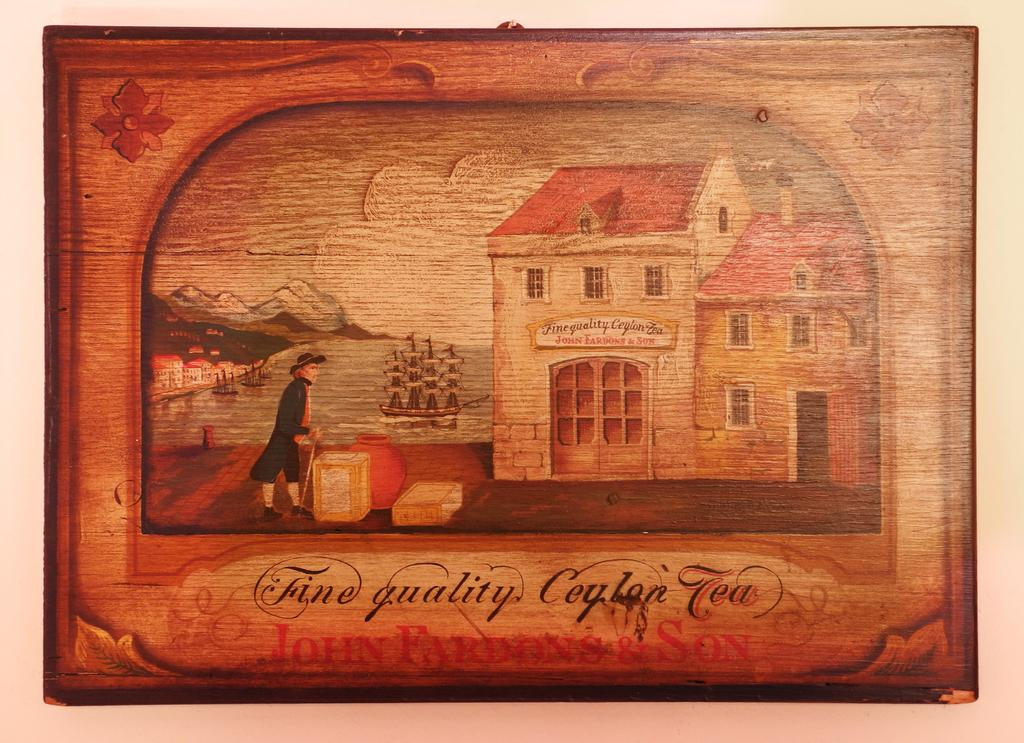<image>
Share a concise interpretation of the image provided. A vintage colonial looking wooden box that holds a fine quality Tea. 